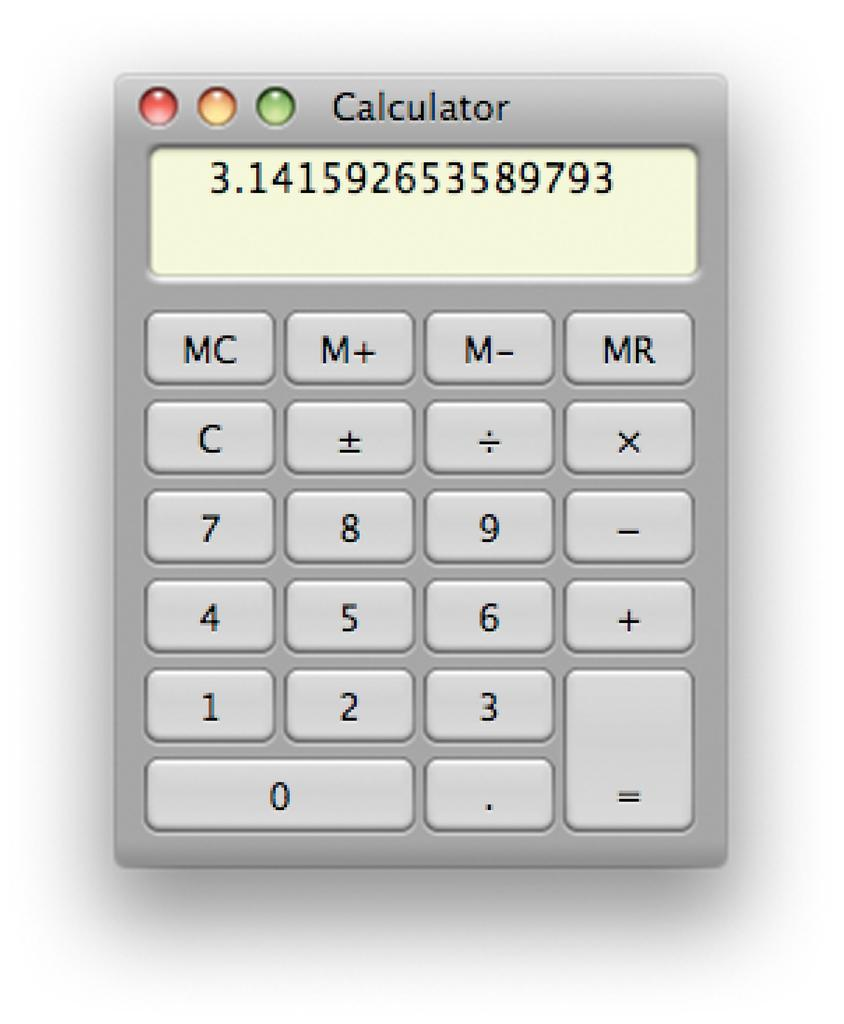<image>
Describe the image concisely. A calculator with the number 3.141592653589793 on the screen. 